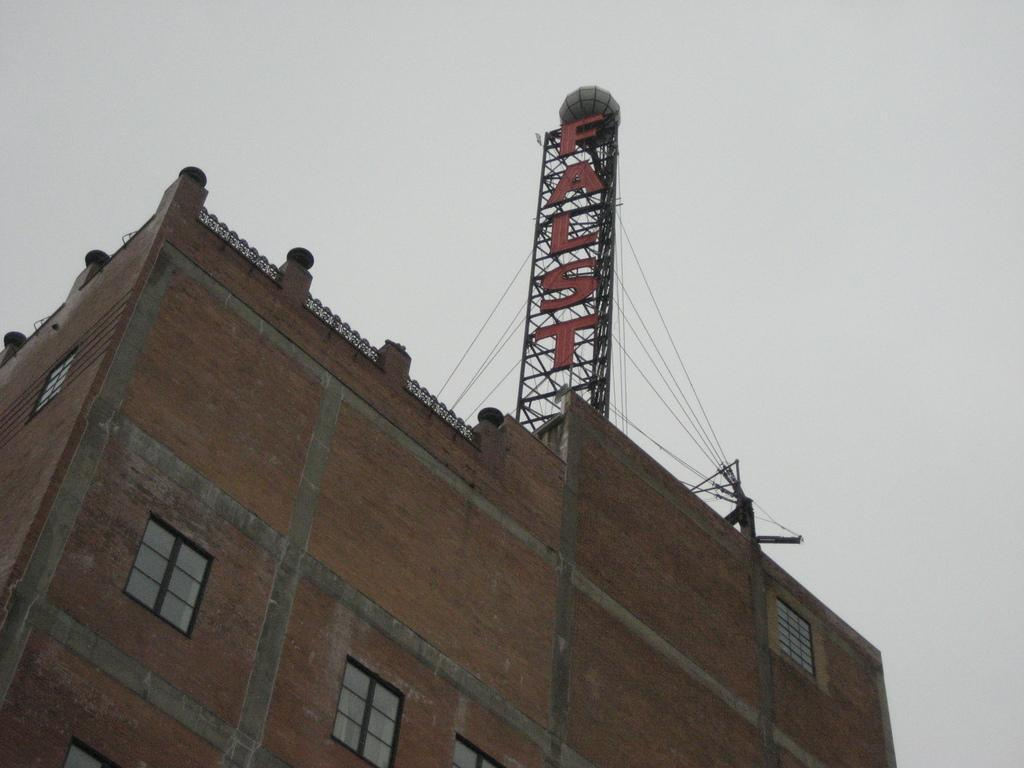What type of structure is present in the image? There is a building in the image. What feature can be seen in the middle of the building? The building has windows in the middle. What is located at the top of the building? There is a hoarding at the top of the building. What type of lighting is used on the hoarding? The hoarding has led lights. What plot of land is the building located on in the image? The provided facts do not mention any specific plot of land, so it cannot be determined from the image. 